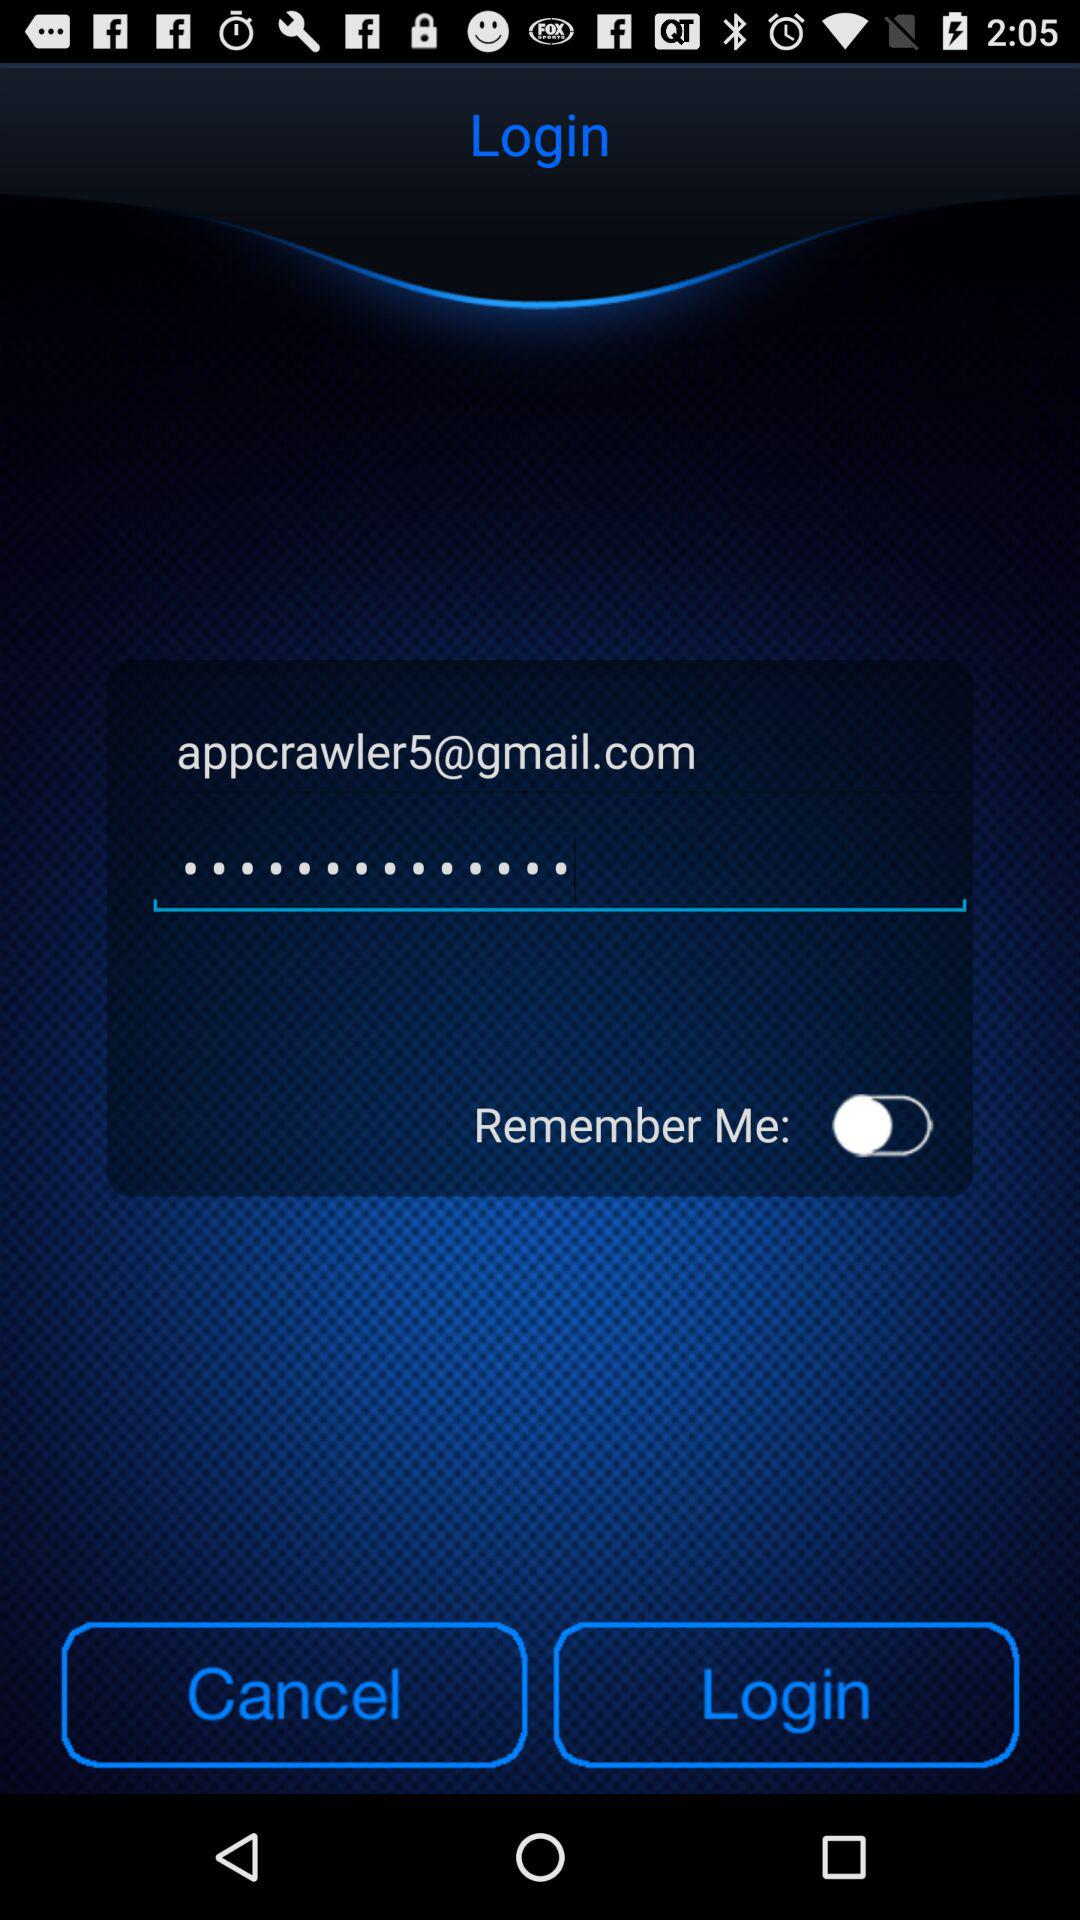What is the email address? The email address is appcrawler5@gmail.com. 